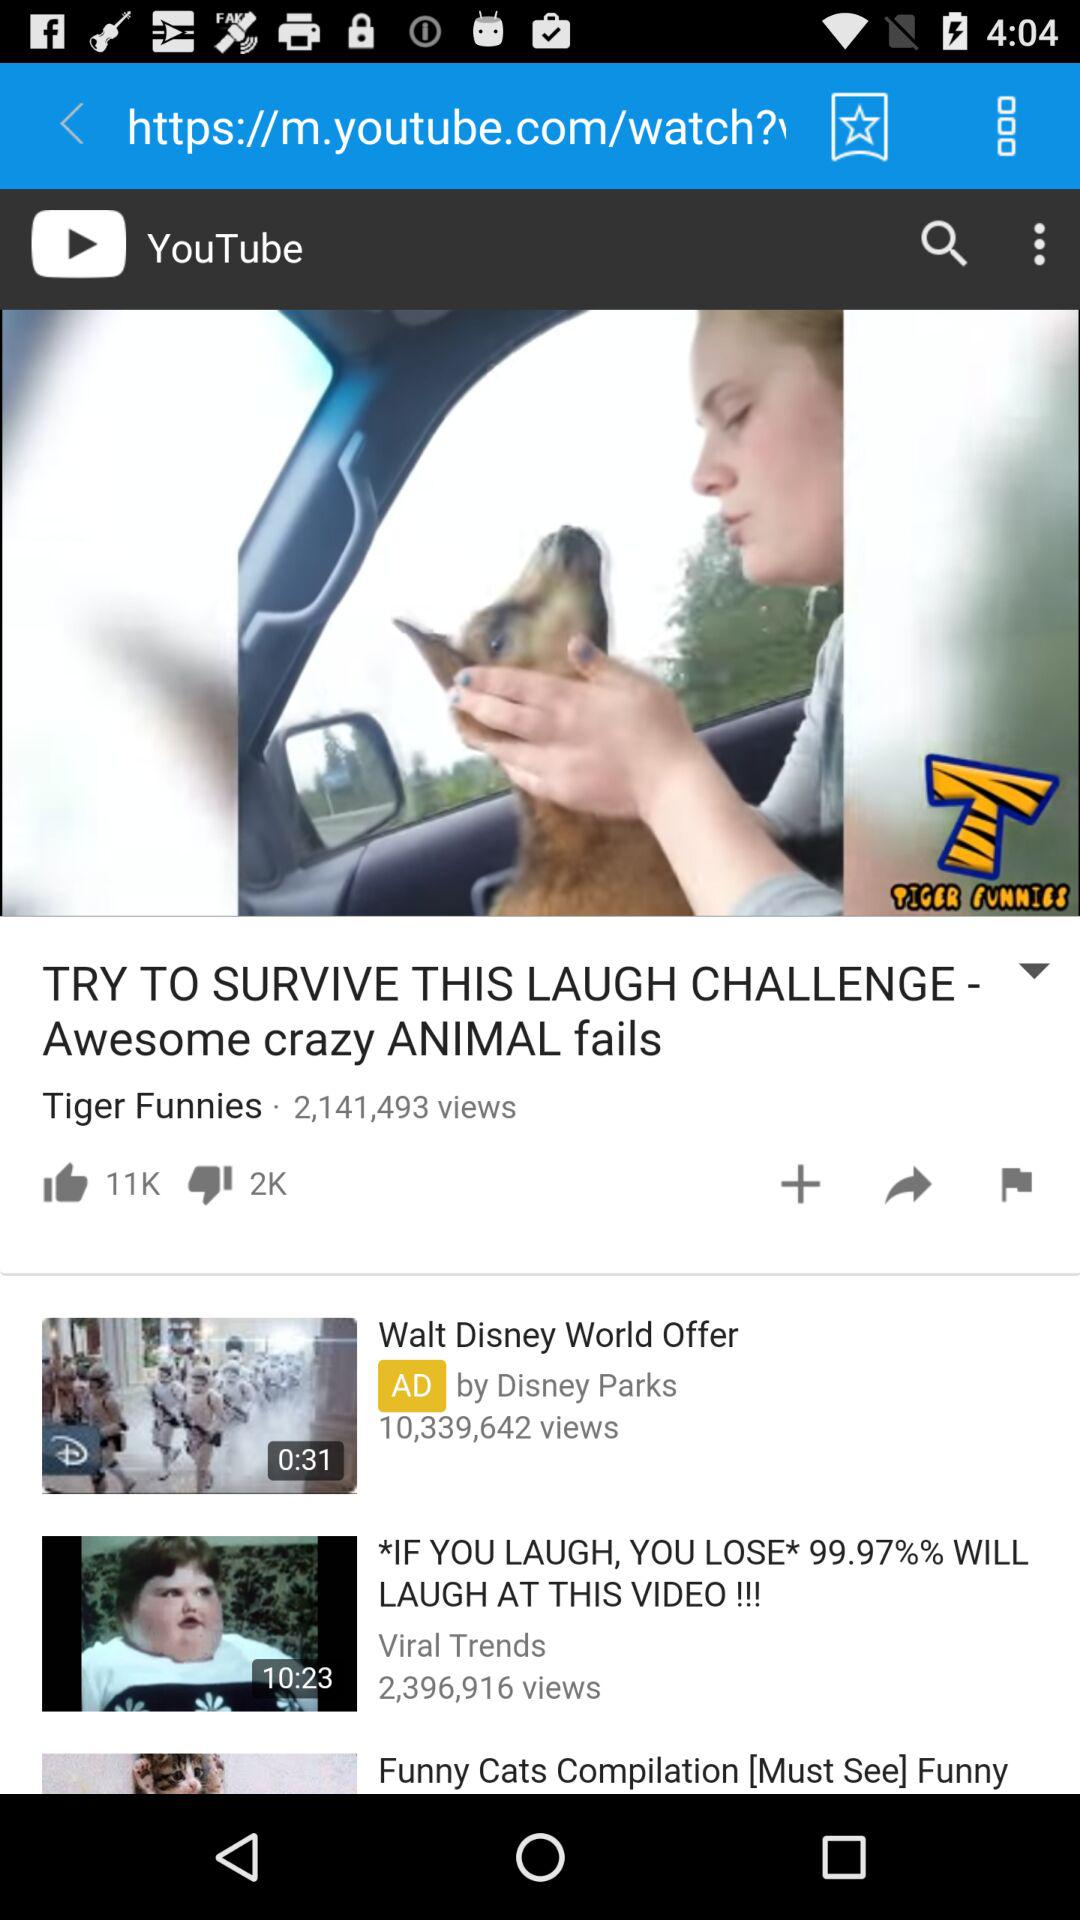What is the duration of the video "*IF YOU LAUGH, YOU LOSE* 99.97%% WILL LAUGH AT THIS VIDEO!!!"? The duration of the video is 10 minutes and 23 seconds. 